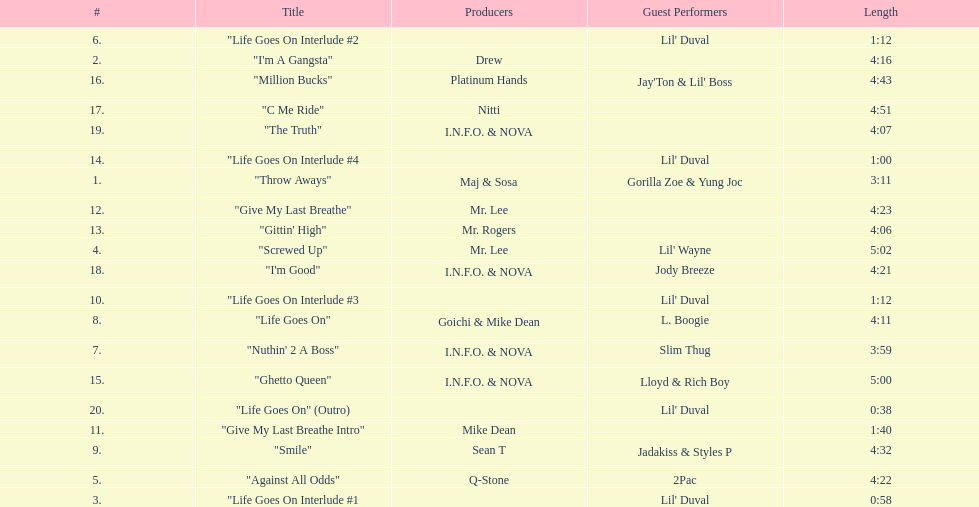How many tracks on trae's album "life goes on"? 20. 